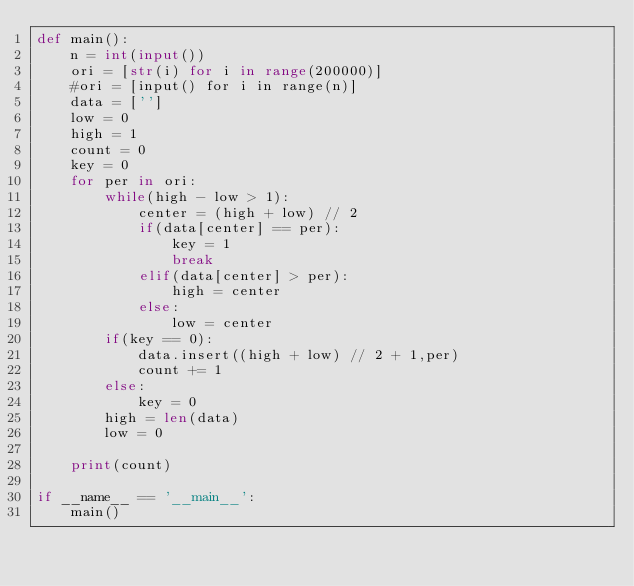<code> <loc_0><loc_0><loc_500><loc_500><_Python_>def main():
    n = int(input())
    ori = [str(i) for i in range(200000)]
    #ori = [input() for i in range(n)]
    data = ['']
    low = 0
    high = 1
    count = 0
    key = 0
    for per in ori:
        while(high - low > 1):
            center = (high + low) // 2
            if(data[center] == per):
                key = 1
                break
            elif(data[center] > per):
                high = center
            else:
                low = center
        if(key == 0):
            data.insert((high + low) // 2 + 1,per)
            count += 1
        else:
            key = 0
        high = len(data)
        low = 0
        
    print(count)

if __name__ == '__main__':
    main()



</code> 